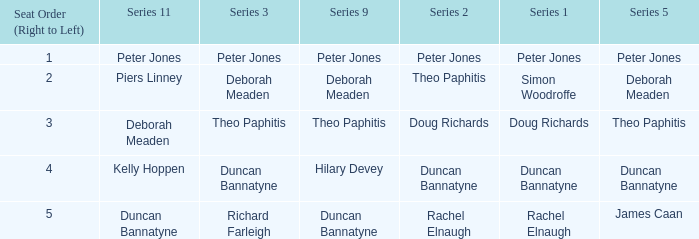How many Seat Orders (Right to Left) have a Series 3 of deborah meaden? 1.0. 